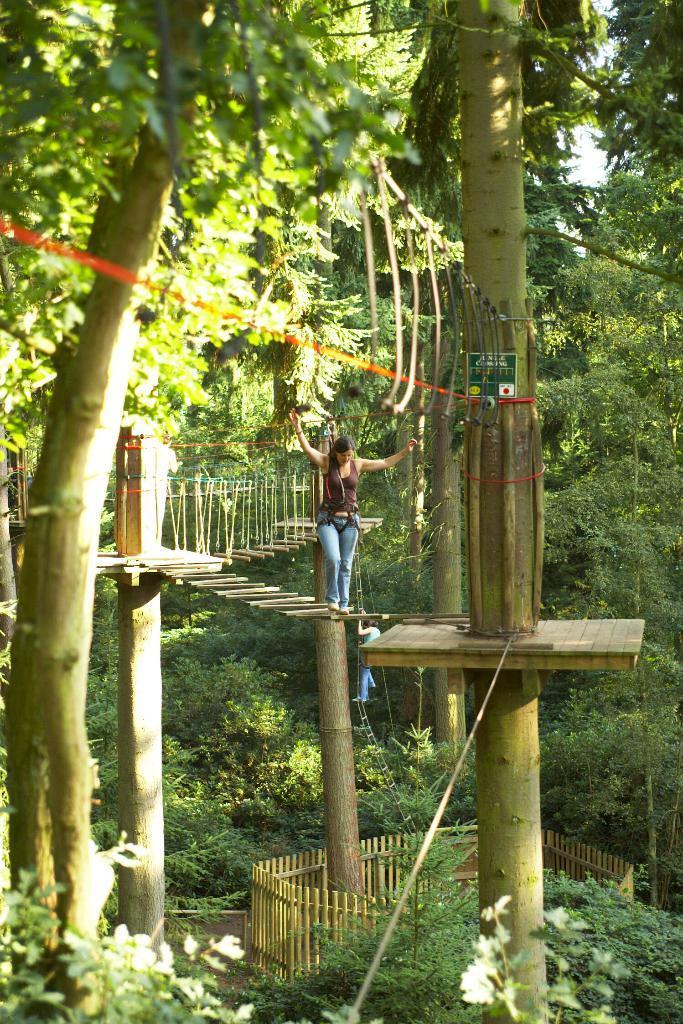Please provide a concise description of this image. In the image we can see a woman wearing clothes and shoes, she is walking. This is a fence, trees, white sky and plants. 